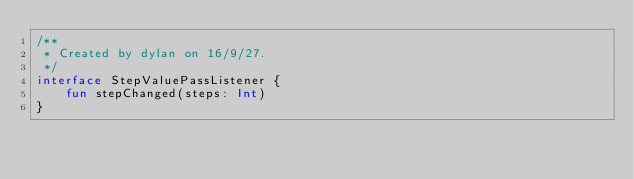Convert code to text. <code><loc_0><loc_0><loc_500><loc_500><_Kotlin_>/**
 * Created by dylan on 16/9/27.
 */
interface StepValuePassListener {
    fun stepChanged(steps: Int)
}</code> 